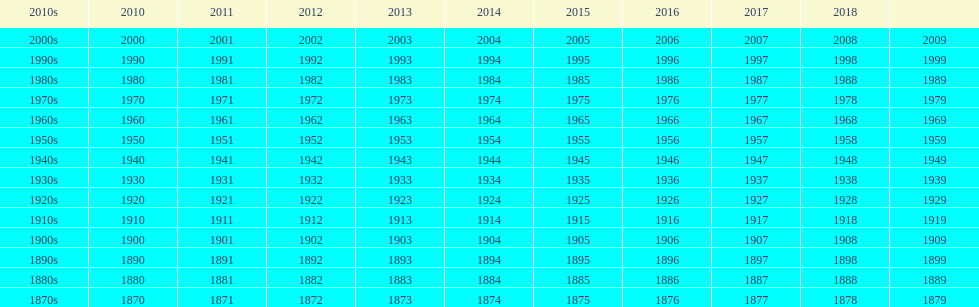True or false: do all years follow a consecutive sequence? True. 